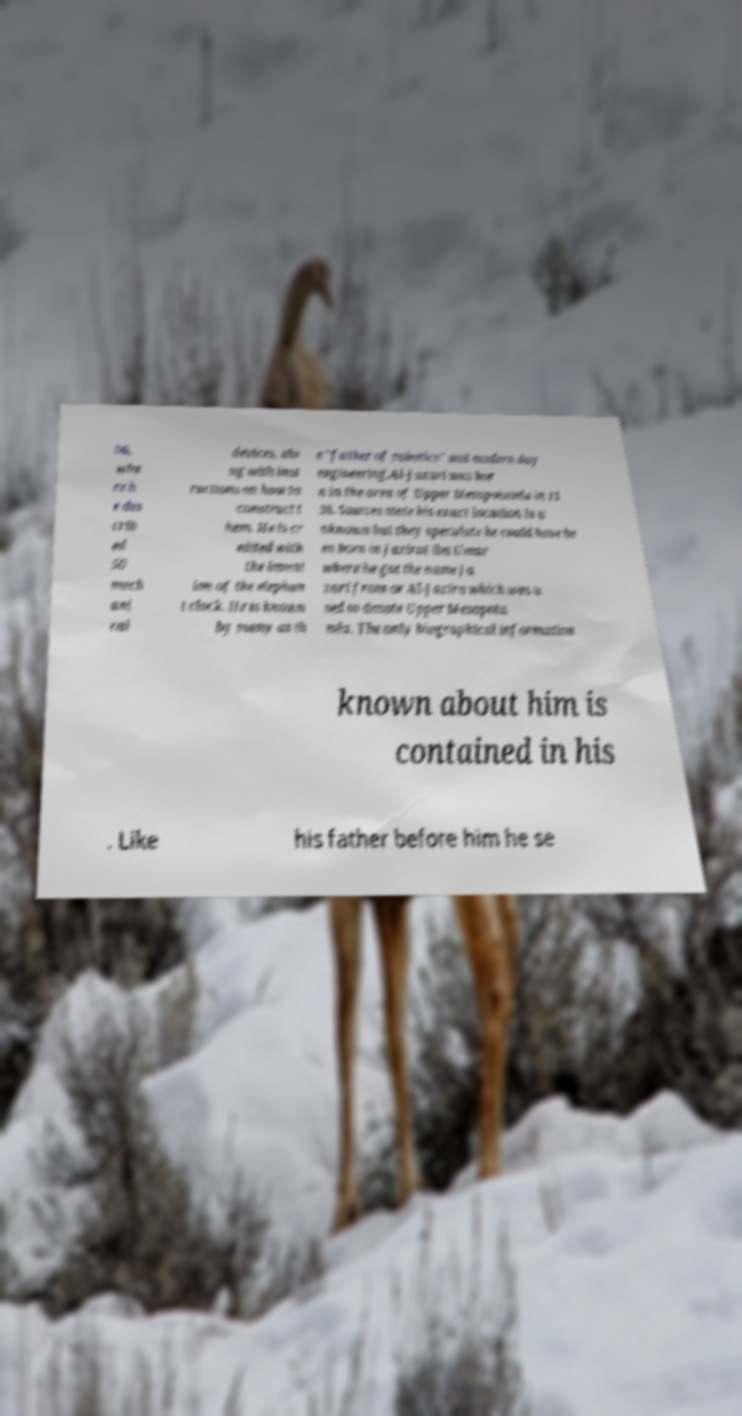For documentation purposes, I need the text within this image transcribed. Could you provide that? 06, whe re h e des crib ed 50 mech ani cal devices, alo ng with inst ructions on how to construct t hem. He is cr edited with the invent ion of the elephan t clock. He is known by many as th e "father of robotics" and modern day engineering.Al-Jazari was bor n in the area of Upper Mesopotamia in 11 36. Sources state his exact location is u nknown but they speculate he could have be en born in Jazirat ibn Umar where he got the name Ja zari from or Al-Jazira which was u sed to denote Upper Mesopota mia. The only biographical information known about him is contained in his . Like his father before him he se 